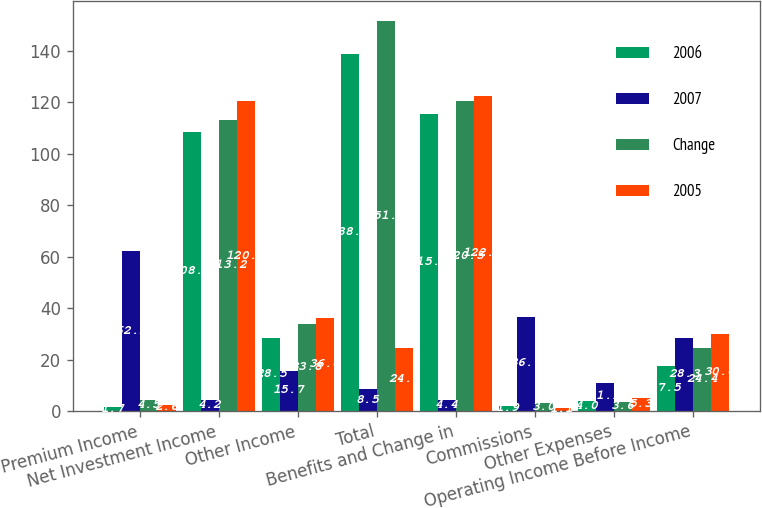Convert chart. <chart><loc_0><loc_0><loc_500><loc_500><stacked_bar_chart><ecel><fcel>Premium Income<fcel>Net Investment Income<fcel>Other Income<fcel>Total<fcel>Benefits and Change in<fcel>Commissions<fcel>Other Expenses<fcel>Operating Income Before Income<nl><fcel>2006<fcel>1.7<fcel>108.4<fcel>28.5<fcel>138.6<fcel>115.2<fcel>1.9<fcel>4<fcel>17.5<nl><fcel>2007<fcel>62.2<fcel>4.2<fcel>15.7<fcel>8.5<fcel>4.4<fcel>36.7<fcel>11.1<fcel>28.3<nl><fcel>Change<fcel>4.5<fcel>113.2<fcel>33.8<fcel>151.5<fcel>120.5<fcel>3<fcel>3.6<fcel>24.4<nl><fcel>2005<fcel>2.6<fcel>120.5<fcel>36<fcel>24.4<fcel>122.2<fcel>1.1<fcel>5.3<fcel>30<nl></chart> 